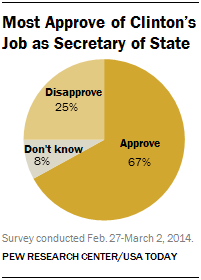What are the percentages for each category shown in this chart? According to the chart, 67% of respondents approve, 25% disapprove, and 8% don't know or have no opinion on the matter being surveyed. What can this chart tell us about public opinion? This chart indicates that a majority of respondents at the time of the survey had a favorable view of Clinton's job performance as Secretary of State, with only a quarter disapproving and a small percentage undecided. 